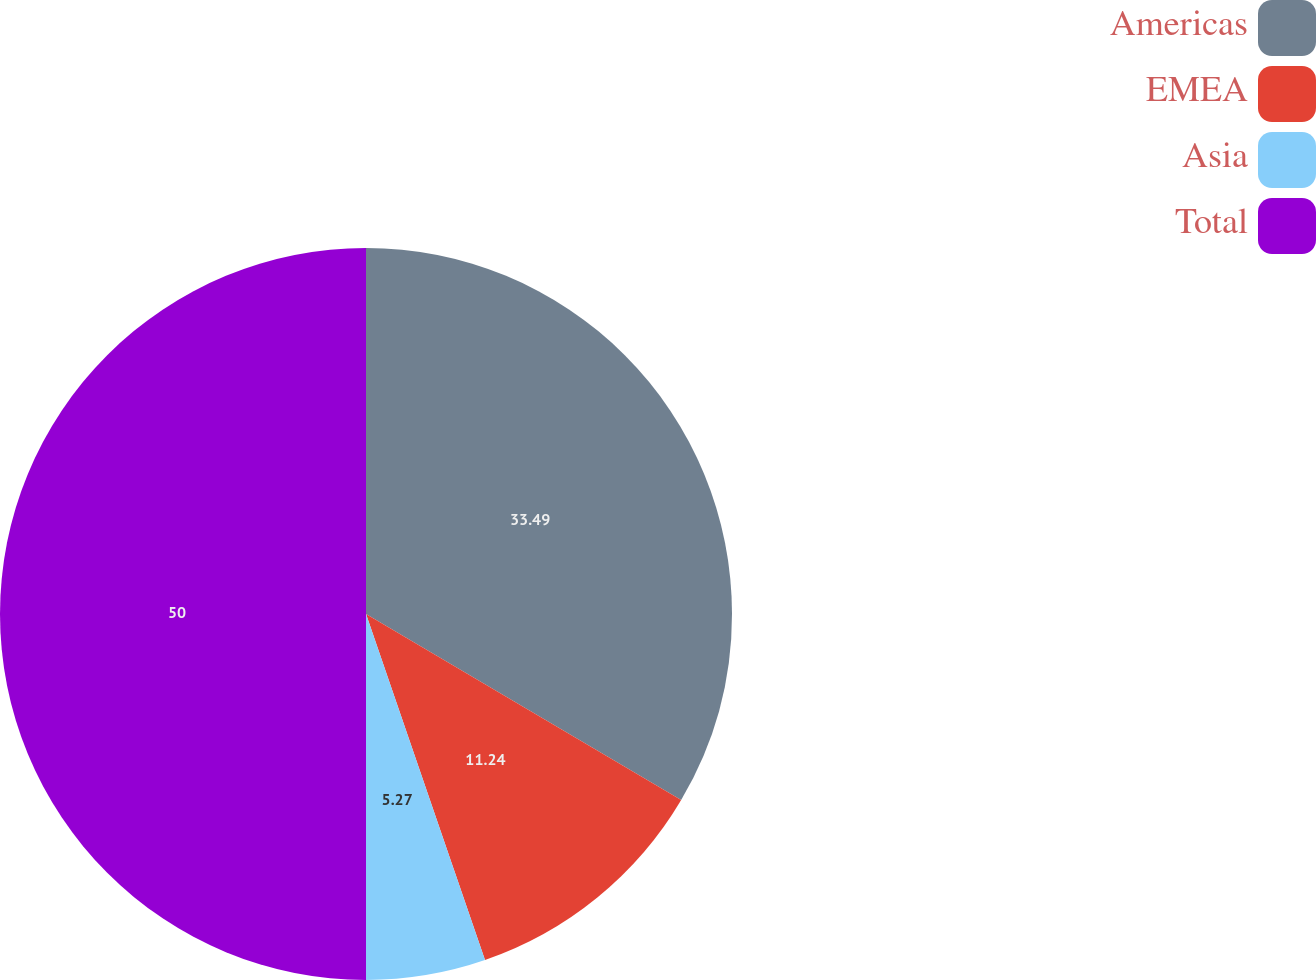Convert chart to OTSL. <chart><loc_0><loc_0><loc_500><loc_500><pie_chart><fcel>Americas<fcel>EMEA<fcel>Asia<fcel>Total<nl><fcel>33.49%<fcel>11.24%<fcel>5.27%<fcel>50.0%<nl></chart> 